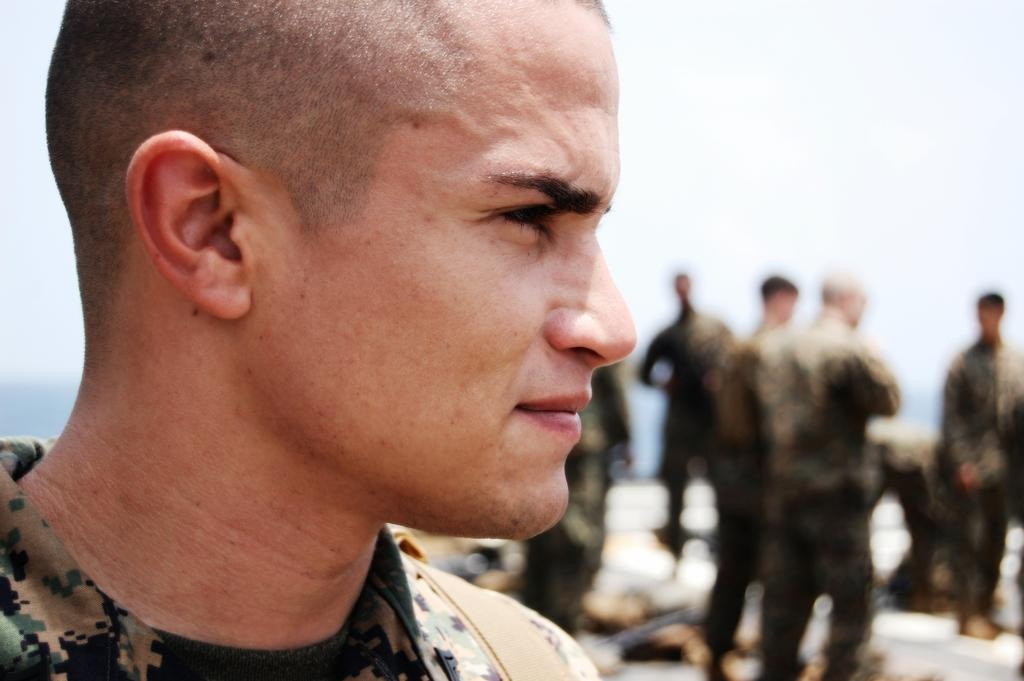Who can be seen in the image? There are people in the image. Can you describe the attire of one of the individuals? A man in the front is wearing a uniform. What can be seen in the distance in the image? The sky is visible in the background of the image. How would you describe the appearance of the background? The background of the image is blurred. What type of copper material is being used to lead the group in the image? There is no copper material or leadership role mentioned in the image. The man in the front is simply wearing a uniform, and there is no indication of him leading a group. 